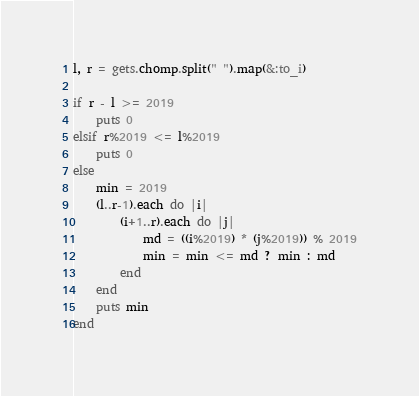Convert code to text. <code><loc_0><loc_0><loc_500><loc_500><_Ruby_>l, r = gets.chomp.split(" ").map(&:to_i)

if r - l >= 2019
    puts 0
elsif r%2019 <= l%2019
    puts 0
else
    min = 2019
    (l..r-1).each do |i|
        (i+1..r).each do |j|
            md = ((i%2019) * (j%2019)) % 2019
            min = min <= md ? min : md
        end
    end
    puts min
end</code> 